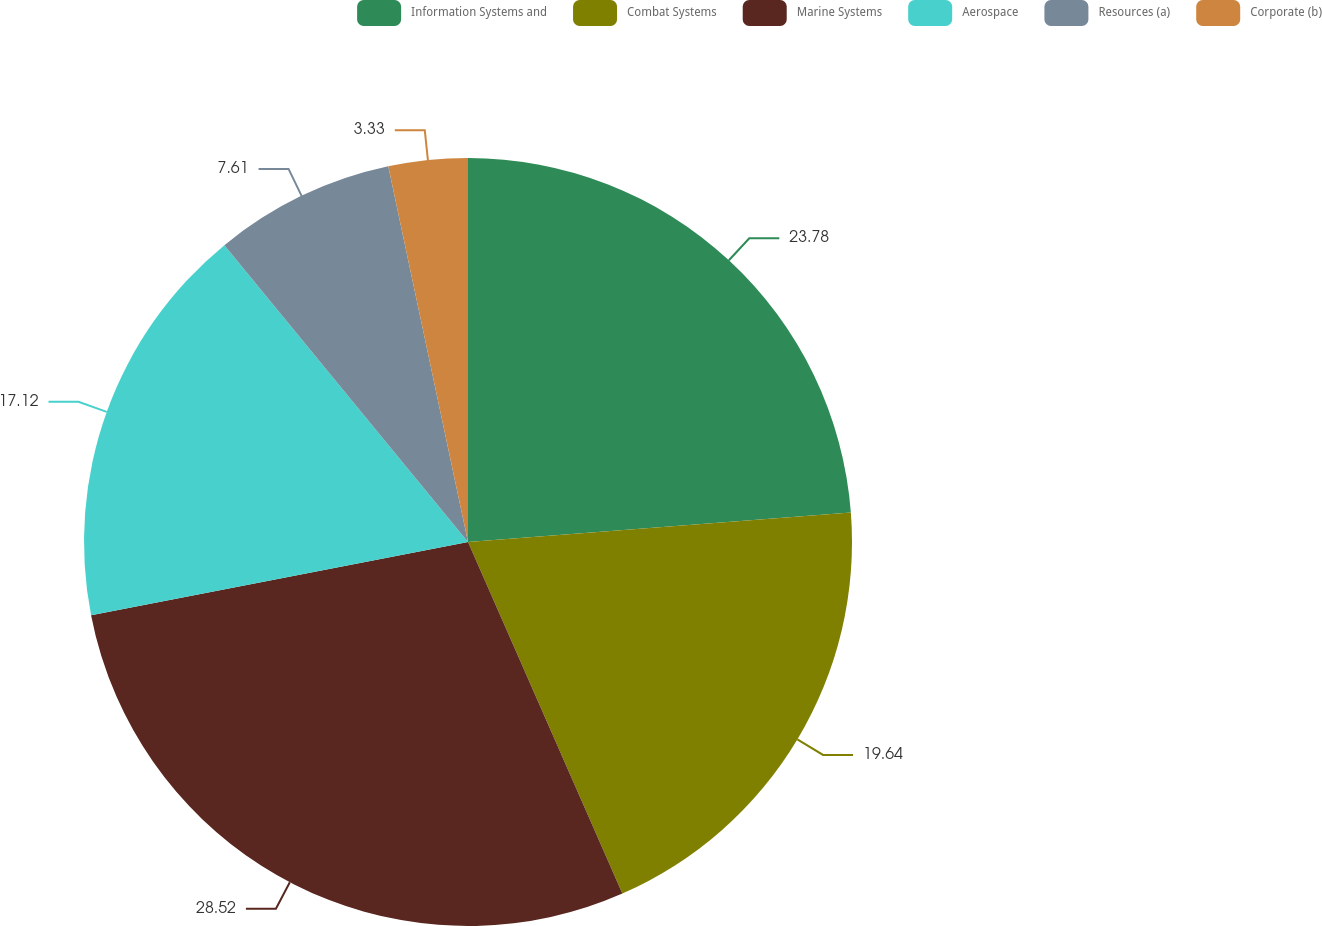<chart> <loc_0><loc_0><loc_500><loc_500><pie_chart><fcel>Information Systems and<fcel>Combat Systems<fcel>Marine Systems<fcel>Aerospace<fcel>Resources (a)<fcel>Corporate (b)<nl><fcel>23.78%<fcel>19.64%<fcel>28.53%<fcel>17.12%<fcel>7.61%<fcel>3.33%<nl></chart> 